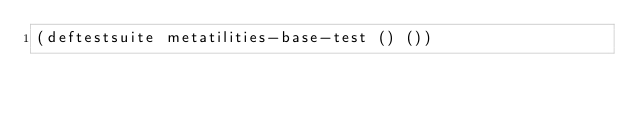<code> <loc_0><loc_0><loc_500><loc_500><_Lisp_>(deftestsuite metatilities-base-test () ())

	   </code> 